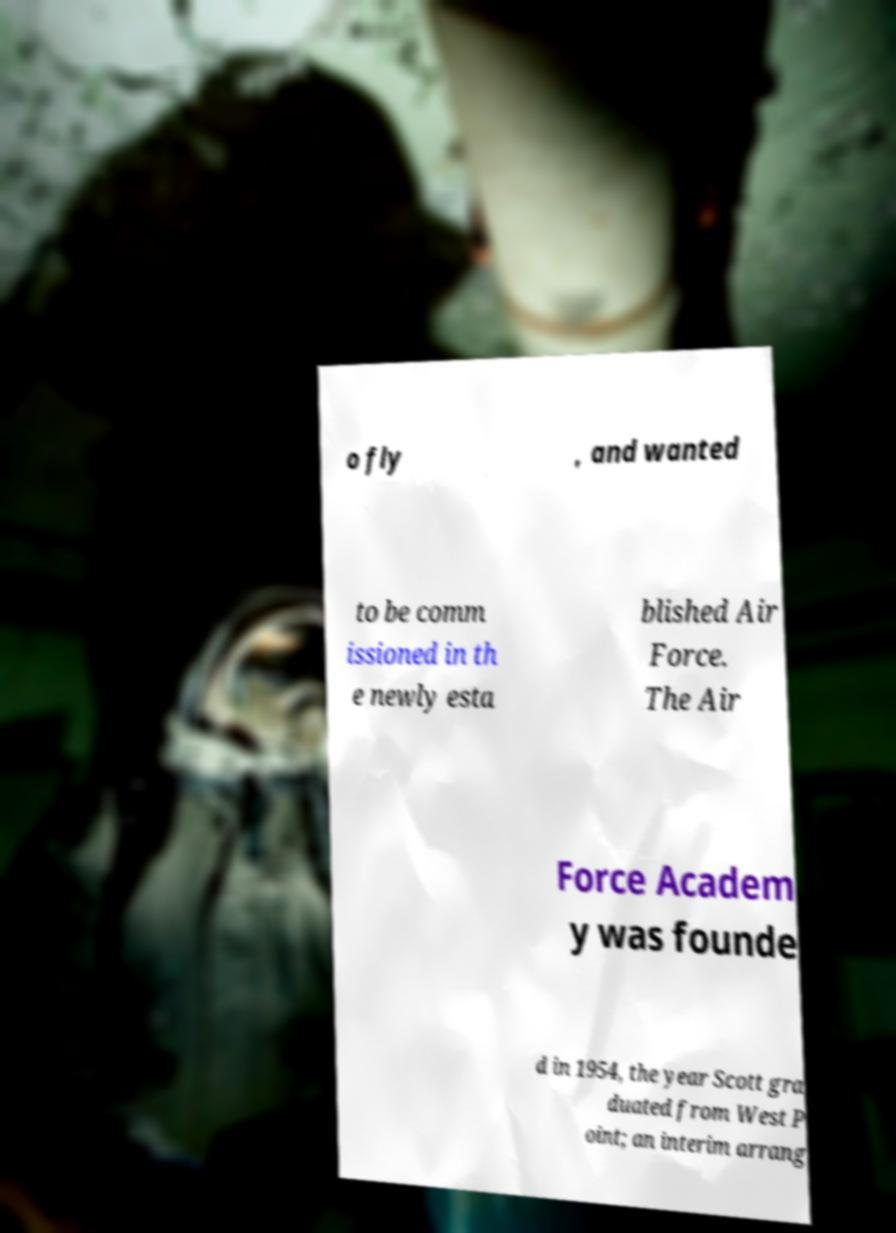Please read and relay the text visible in this image. What does it say? o fly , and wanted to be comm issioned in th e newly esta blished Air Force. The Air Force Academ y was founde d in 1954, the year Scott gra duated from West P oint; an interim arrang 